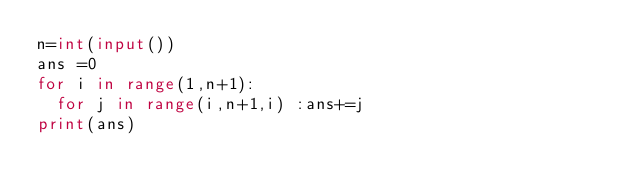Convert code to text. <code><loc_0><loc_0><loc_500><loc_500><_Python_>n=int(input())
ans =0
for i in range(1,n+1):
	for j in range(i,n+1,i) :ans+=j
print(ans)
</code> 